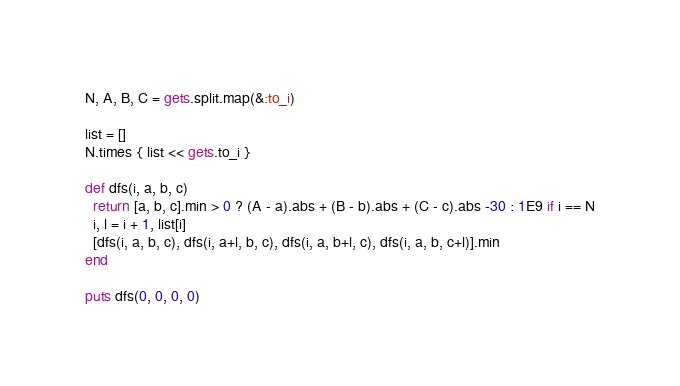<code> <loc_0><loc_0><loc_500><loc_500><_Ruby_>N, A, B, C = gets.split.map(&:to_i)

list = []
N.times { list << gets.to_i }

def dfs(i, a, b, c)
  return [a, b, c].min > 0 ? (A - a).abs + (B - b).abs + (C - c).abs -30 : 1E9 if i == N
  i, l = i + 1, list[i]
  [dfs(i, a, b, c), dfs(i, a+l, b, c), dfs(i, a, b+l, c), dfs(i, a, b, c+l)].min
end

puts dfs(0, 0, 0, 0)</code> 